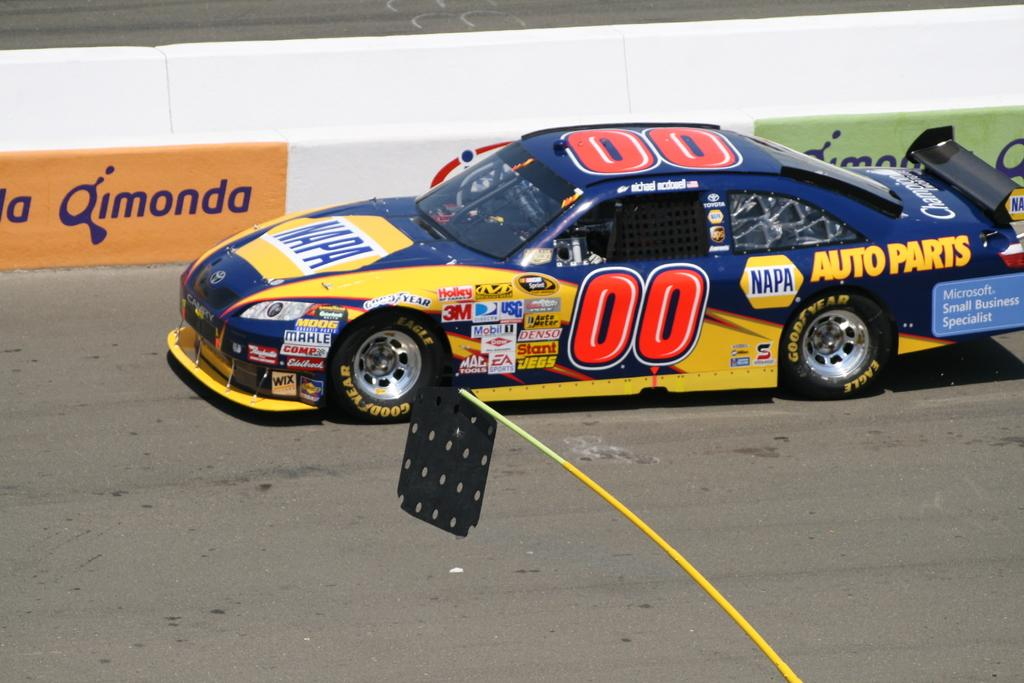What is the main subject of the image? The main subject of the image is a car on the road. What else can be seen in the image besides the car? There is a wall with text and a stick with an object in the image. What type of riddle is being solved by the car in the image? There is no riddle being solved by the car in the image; it is simply a car on the road. What thrilling activity is taking place in the image? There is no thrilling activity depicted in the image; it shows a car on the road and other objects. 